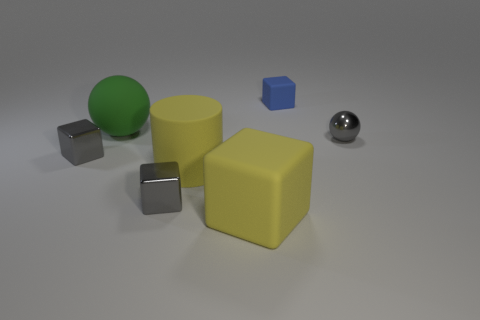Subtract all small blue blocks. How many blocks are left? 3 Add 2 green rubber things. How many objects exist? 9 Subtract all gray blocks. How many blocks are left? 2 Subtract all cylinders. How many objects are left? 6 Subtract all gray cylinders. Subtract all cyan blocks. How many cylinders are left? 1 Subtract all brown blocks. How many cyan cylinders are left? 0 Subtract all large yellow metallic objects. Subtract all large yellow matte blocks. How many objects are left? 6 Add 4 yellow rubber cubes. How many yellow rubber cubes are left? 5 Add 7 large green rubber objects. How many large green rubber objects exist? 8 Subtract 0 green blocks. How many objects are left? 7 